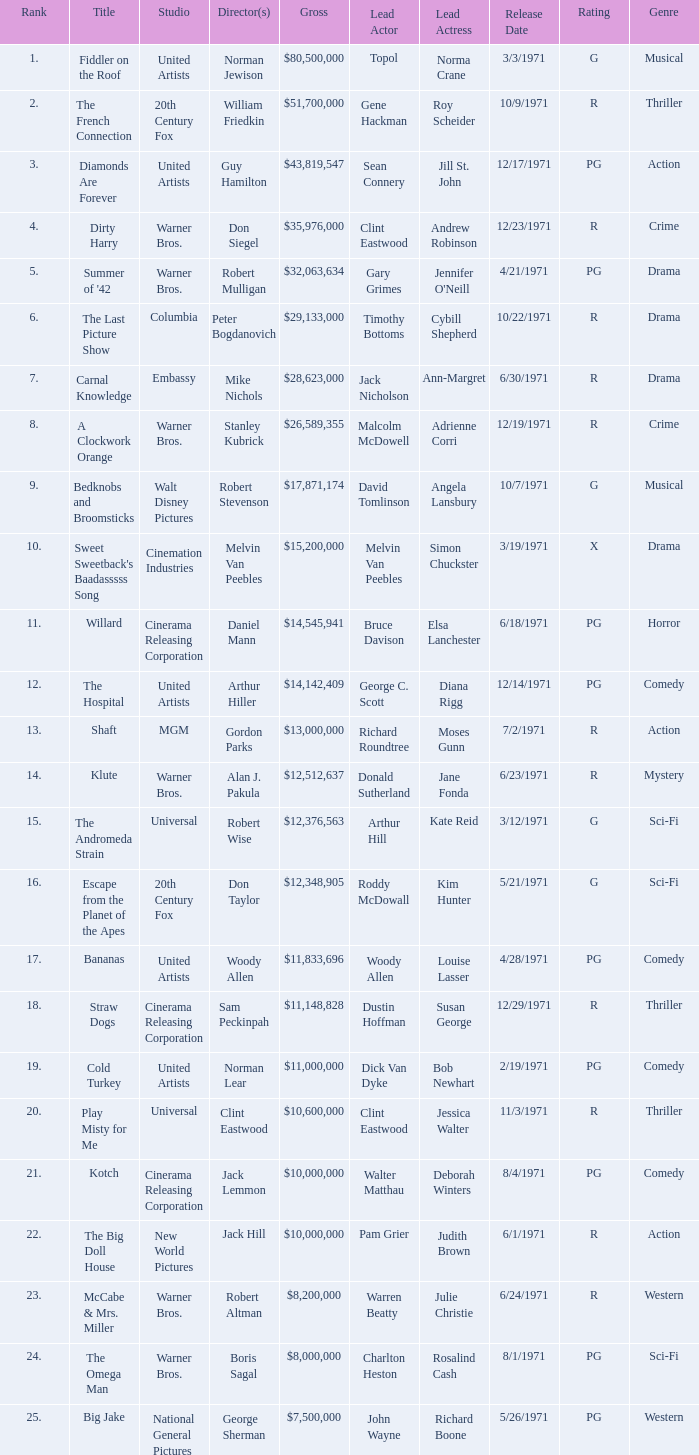Which title ranked lower than 19 has a gross of $11,833,696? Bananas. Give me the full table as a dictionary. {'header': ['Rank', 'Title', 'Studio', 'Director(s)', 'Gross', 'Lead Actor', 'Lead Actress', 'Release Date', 'Rating', 'Genre'], 'rows': [['1.', 'Fiddler on the Roof', 'United Artists', 'Norman Jewison', '$80,500,000', 'Topol', 'Norma Crane', '3/3/1971', 'G', 'Musical'], ['2.', 'The French Connection', '20th Century Fox', 'William Friedkin', '$51,700,000', 'Gene Hackman', 'Roy Scheider', '10/9/1971', 'R', 'Thriller'], ['3.', 'Diamonds Are Forever', 'United Artists', 'Guy Hamilton', '$43,819,547', 'Sean Connery', 'Jill St. John', '12/17/1971', 'PG', 'Action'], ['4.', 'Dirty Harry', 'Warner Bros.', 'Don Siegel', '$35,976,000', 'Clint Eastwood', 'Andrew Robinson', '12/23/1971', 'R', 'Crime'], ['5.', "Summer of '42", 'Warner Bros.', 'Robert Mulligan', '$32,063,634', 'Gary Grimes', "Jennifer O'Neill", '4/21/1971', 'PG', 'Drama'], ['6.', 'The Last Picture Show', 'Columbia', 'Peter Bogdanovich', '$29,133,000', 'Timothy Bottoms', 'Cybill Shepherd', '10/22/1971', 'R', 'Drama'], ['7.', 'Carnal Knowledge', 'Embassy', 'Mike Nichols', '$28,623,000', 'Jack Nicholson', 'Ann-Margret', '6/30/1971', 'R', 'Drama'], ['8.', 'A Clockwork Orange', 'Warner Bros.', 'Stanley Kubrick', '$26,589,355', 'Malcolm McDowell', 'Adrienne Corri', '12/19/1971', 'R', 'Crime'], ['9.', 'Bedknobs and Broomsticks', 'Walt Disney Pictures', 'Robert Stevenson', '$17,871,174', 'David Tomlinson', 'Angela Lansbury', '10/7/1971', 'G', 'Musical'], ['10.', "Sweet Sweetback's Baadasssss Song", 'Cinemation Industries', 'Melvin Van Peebles', '$15,200,000', 'Melvin Van Peebles', 'Simon Chuckster', '3/19/1971', 'X', 'Drama'], ['11.', 'Willard', 'Cinerama Releasing Corporation', 'Daniel Mann', '$14,545,941', 'Bruce Davison', 'Elsa Lanchester', '6/18/1971', 'PG', 'Horror'], ['12.', 'The Hospital', 'United Artists', 'Arthur Hiller', '$14,142,409', 'George C. Scott', 'Diana Rigg', '12/14/1971', 'PG', 'Comedy'], ['13.', 'Shaft', 'MGM', 'Gordon Parks', '$13,000,000', 'Richard Roundtree', 'Moses Gunn', '7/2/1971', 'R', 'Action'], ['14.', 'Klute', 'Warner Bros.', 'Alan J. Pakula', '$12,512,637', 'Donald Sutherland', 'Jane Fonda', '6/23/1971', 'R', 'Mystery'], ['15.', 'The Andromeda Strain', 'Universal', 'Robert Wise', '$12,376,563', 'Arthur Hill', 'Kate Reid', '3/12/1971', 'G', 'Sci-Fi'], ['16.', 'Escape from the Planet of the Apes', '20th Century Fox', 'Don Taylor', '$12,348,905', 'Roddy McDowall', 'Kim Hunter', '5/21/1971', 'G', 'Sci-Fi'], ['17.', 'Bananas', 'United Artists', 'Woody Allen', '$11,833,696', 'Woody Allen', 'Louise Lasser', '4/28/1971', 'PG', 'Comedy'], ['18.', 'Straw Dogs', 'Cinerama Releasing Corporation', 'Sam Peckinpah', '$11,148,828', 'Dustin Hoffman', 'Susan George', '12/29/1971', 'R', 'Thriller'], ['19.', 'Cold Turkey', 'United Artists', 'Norman Lear', '$11,000,000', 'Dick Van Dyke', 'Bob Newhart', '2/19/1971', 'PG', 'Comedy'], ['20.', 'Play Misty for Me', 'Universal', 'Clint Eastwood', '$10,600,000', 'Clint Eastwood', 'Jessica Walter', '11/3/1971', 'R', 'Thriller'], ['21.', 'Kotch', 'Cinerama Releasing Corporation', 'Jack Lemmon', '$10,000,000', 'Walter Matthau', 'Deborah Winters', '8/4/1971', 'PG', 'Comedy'], ['22.', 'The Big Doll House', 'New World Pictures', 'Jack Hill', '$10,000,000', 'Pam Grier', 'Judith Brown', '6/1/1971', 'R', 'Action'], ['23.', 'McCabe & Mrs. Miller', 'Warner Bros.', 'Robert Altman', '$8,200,000', 'Warren Beatty', 'Julie Christie', '6/24/1971', 'R', 'Western'], ['24.', 'The Omega Man', 'Warner Bros.', 'Boris Sagal', '$8,000,000', 'Charlton Heston', 'Rosalind Cash', '8/1/1971', 'PG', 'Sci-Fi'], ['25.', 'Big Jake', 'National General Pictures', 'George Sherman', '$7,500,000', 'John Wayne', 'Richard Boone', '5/26/1971', 'PG', 'Western']]} 